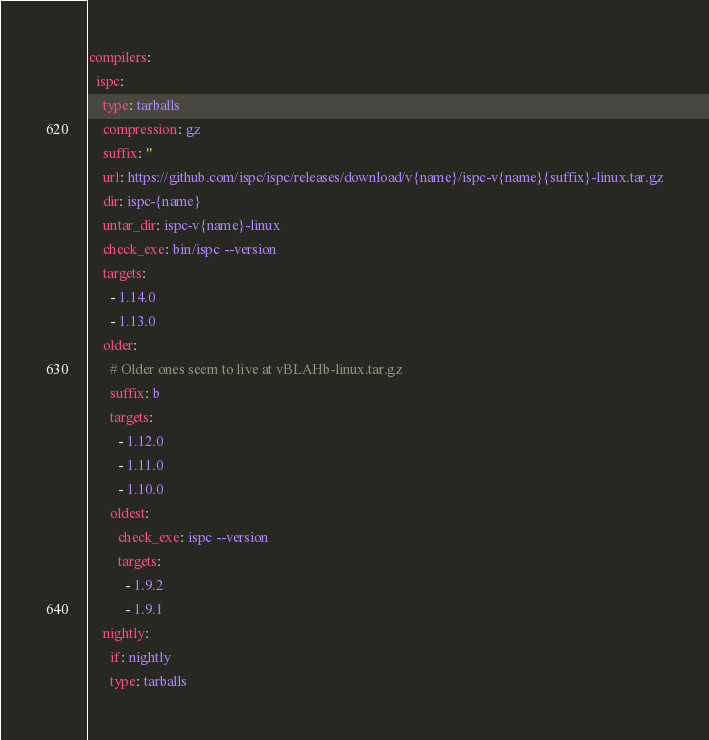<code> <loc_0><loc_0><loc_500><loc_500><_YAML_>compilers:
  ispc:
    type: tarballs
    compression: gz
    suffix: ''
    url: https://github.com/ispc/ispc/releases/download/v{name}/ispc-v{name}{suffix}-linux.tar.gz
    dir: ispc-{name}
    untar_dir: ispc-v{name}-linux
    check_exe: bin/ispc --version
    targets:
      - 1.14.0
      - 1.13.0
    older:
      # Older ones seem to live at vBLAHb-linux.tar.gz
      suffix: b
      targets:
        - 1.12.0
        - 1.11.0
        - 1.10.0
      oldest:
        check_exe: ispc --version
        targets:
          - 1.9.2
          - 1.9.1
    nightly:
      if: nightly
      type: tarballs</code> 